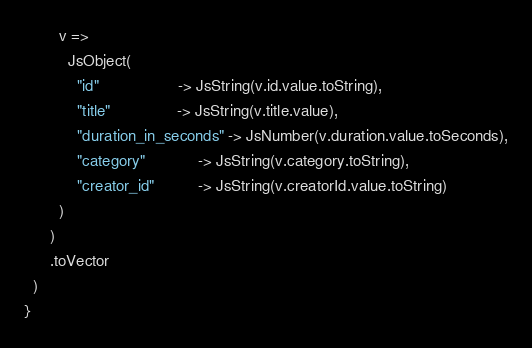<code> <loc_0><loc_0><loc_500><loc_500><_Scala_>        v =>
          JsObject(
            "id"                  -> JsString(v.id.value.toString),
            "title"               -> JsString(v.title.value),
            "duration_in_seconds" -> JsNumber(v.duration.value.toSeconds),
            "category"            -> JsString(v.category.toString),
            "creator_id"          -> JsString(v.creatorId.value.toString)
        )
      )
      .toVector
  )
}
</code> 